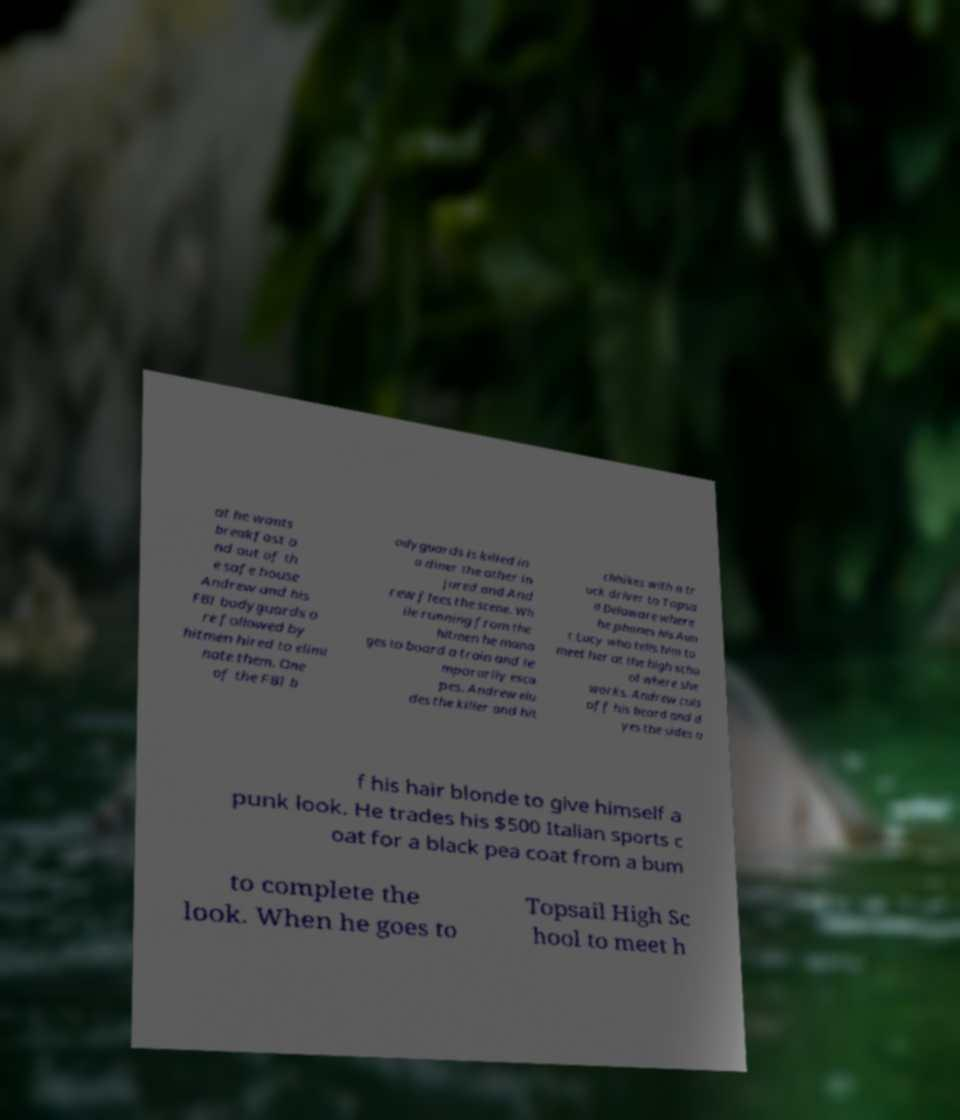Please read and relay the text visible in this image. What does it say? at he wants breakfast a nd out of th e safe house Andrew and his FBI bodyguards a re followed by hitmen hired to elimi nate them. One of the FBI b odyguards is killed in a diner the other in jured and And rew flees the scene. Wh ile running from the hitmen he mana ges to board a train and te mporarily esca pes. Andrew elu des the killer and hit chhikes with a tr uck driver to Topsa il Delaware where he phones his Aun t Lucy who tells him to meet her at the high scho ol where she works. Andrew cuts off his beard and d yes the sides o f his hair blonde to give himself a punk look. He trades his $500 Italian sports c oat for a black pea coat from a bum to complete the look. When he goes to Topsail High Sc hool to meet h 